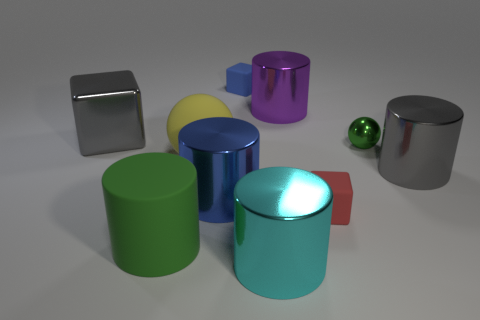Subtract 1 blocks. How many blocks are left? 2 Subtract all purple cylinders. How many cylinders are left? 4 Subtract all purple cylinders. How many cylinders are left? 4 Subtract all blue cylinders. Subtract all brown cubes. How many cylinders are left? 4 Subtract all balls. How many objects are left? 8 Add 6 spheres. How many spheres exist? 8 Subtract 1 yellow spheres. How many objects are left? 9 Subtract all large cyan shiny things. Subtract all green metal things. How many objects are left? 8 Add 3 big green matte things. How many big green matte things are left? 4 